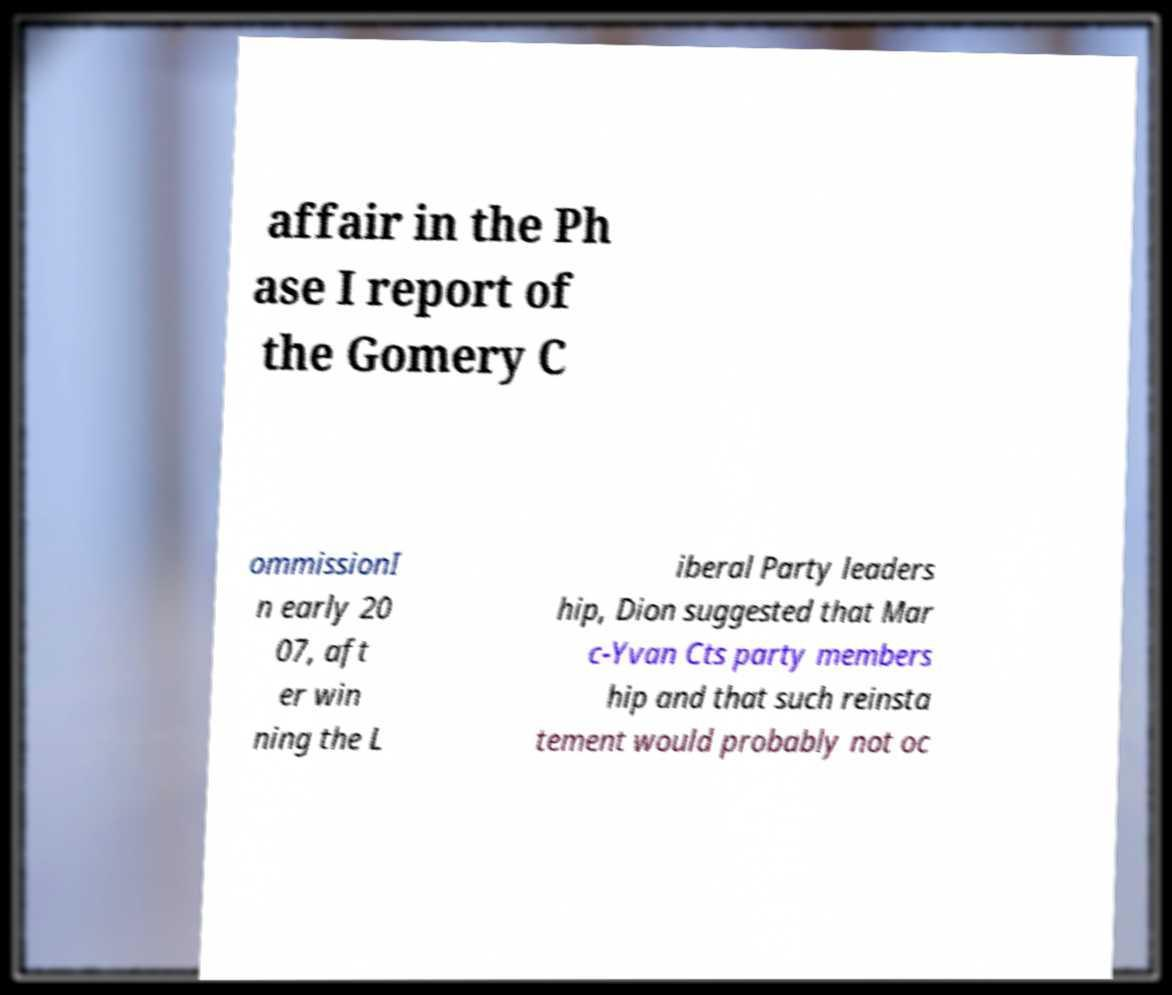Can you accurately transcribe the text from the provided image for me? affair in the Ph ase I report of the Gomery C ommissionI n early 20 07, aft er win ning the L iberal Party leaders hip, Dion suggested that Mar c-Yvan Cts party members hip and that such reinsta tement would probably not oc 